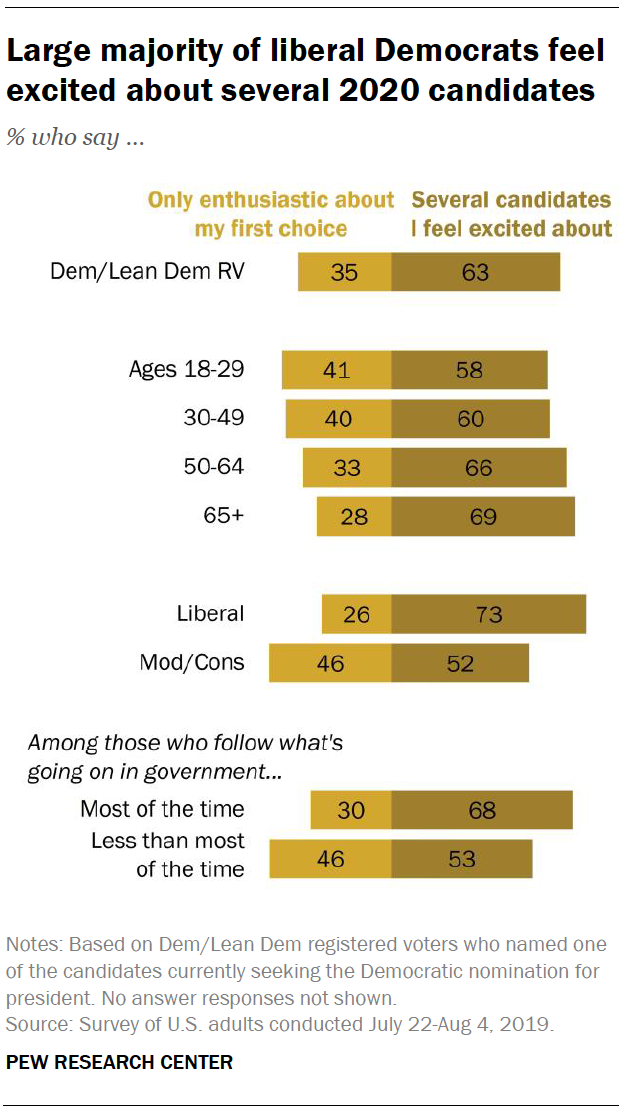Highlight a few significant elements in this photo. What is the difference in value between the liberal bar and 47? What is the smallest value in the brown bar? It is 52. 